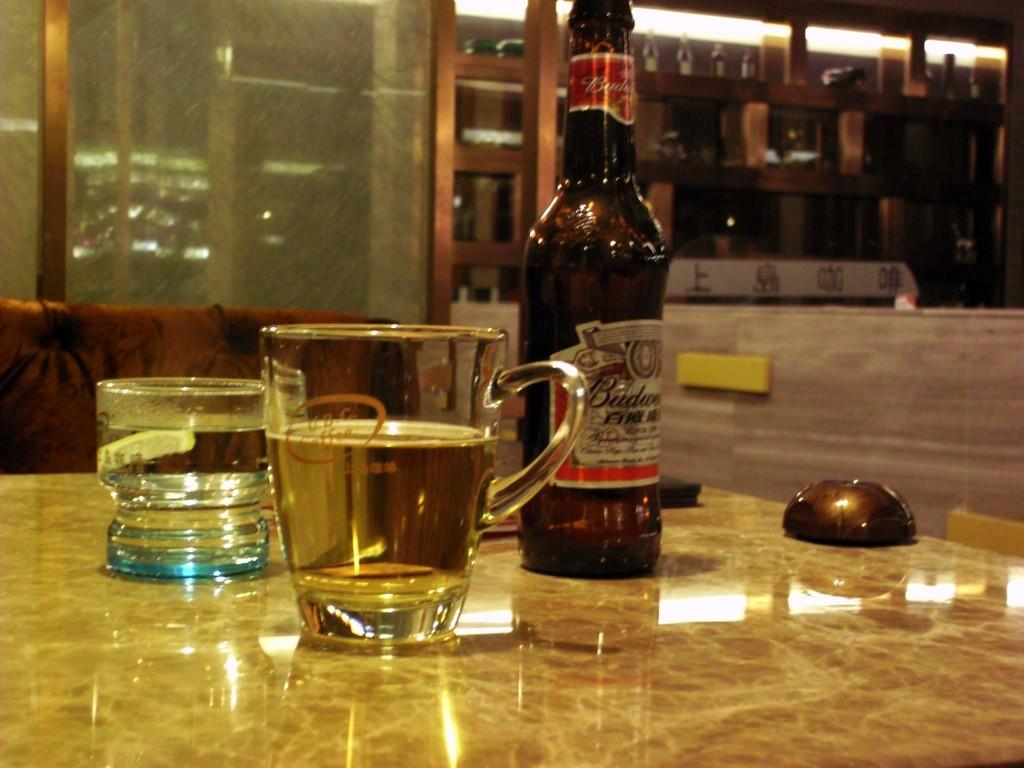<image>
Present a compact description of the photo's key features. A table in a bar with two glasses and a Budweiser bottle 